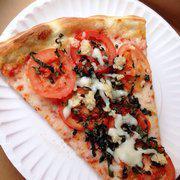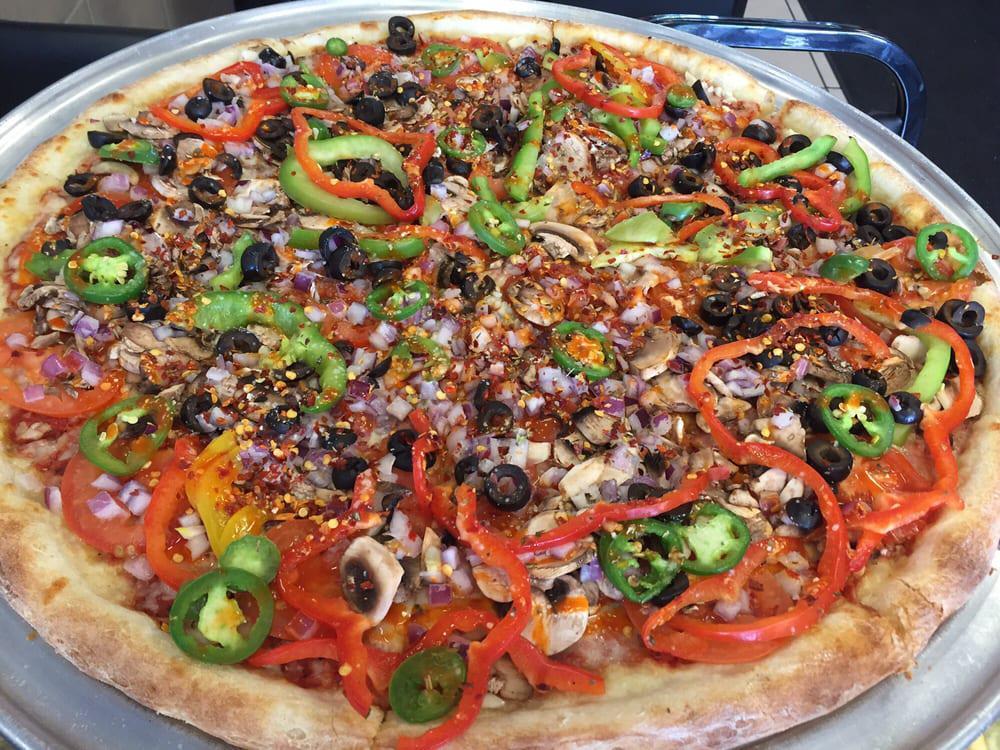The first image is the image on the left, the second image is the image on the right. Analyze the images presented: Is the assertion "One image shows a whole pizza with black olives and red pepper strips on top, and the other image shows no more than two wedge-shaped slices on something made of paper." valid? Answer yes or no. Yes. The first image is the image on the left, the second image is the image on the right. Assess this claim about the two images: "There are two whole pizzas ready to eat.". Correct or not? Answer yes or no. No. 